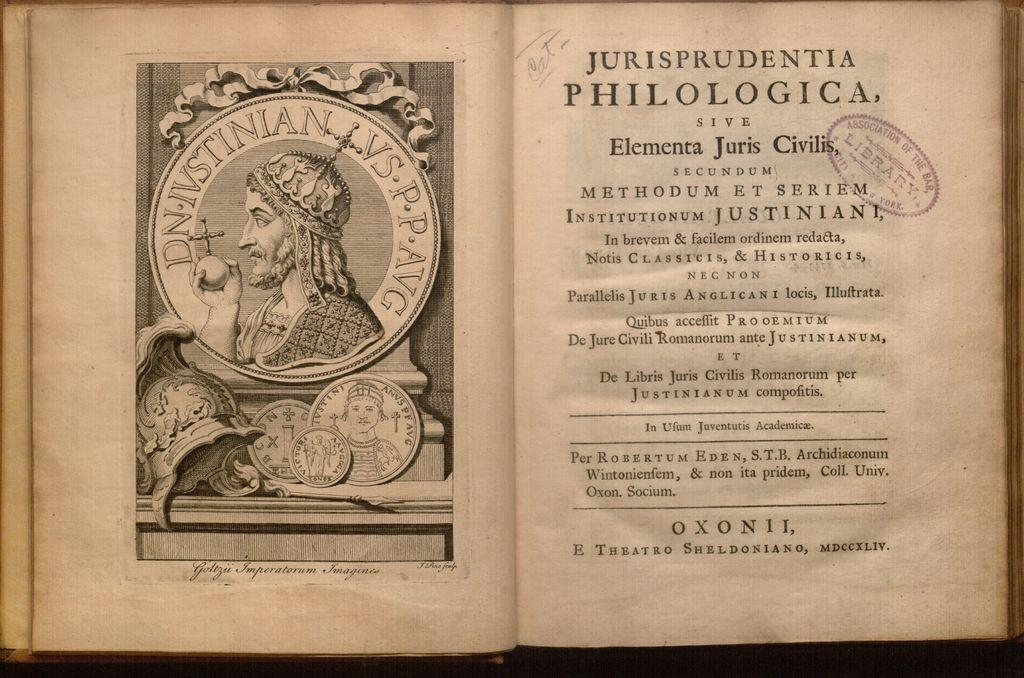What is the main object in the image? There is an open book in the image. What can be seen on the left side of the book? There is an image on the left side of the book. What is present on the right side of the book? There is some matter (text or content) on the right side of the book. Can you describe any additional elements on the right side of the book? Yes, a stamp is present on the right side of the book. What color is the leaf on the right side of the book? There is no mention of a leaf in the image. The focus is on the open book, its contents, and the presence of a stamp on the right side of the book. 